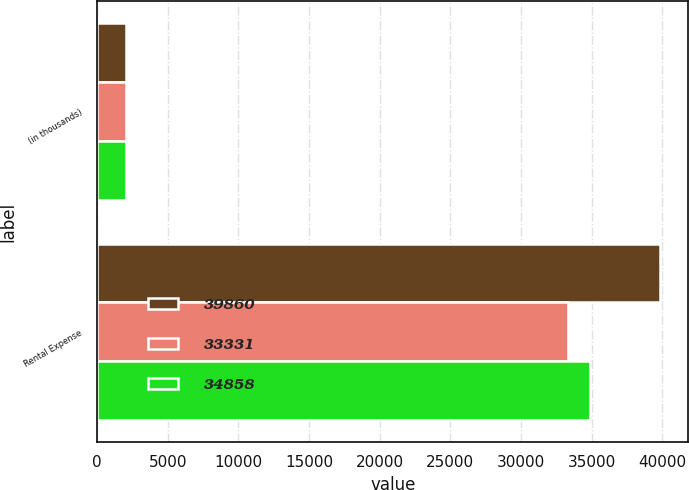<chart> <loc_0><loc_0><loc_500><loc_500><stacked_bar_chart><ecel><fcel>(in thousands)<fcel>Rental Expense<nl><fcel>39860<fcel>2008<fcel>39860<nl><fcel>33331<fcel>2007<fcel>33331<nl><fcel>34858<fcel>2006<fcel>34858<nl></chart> 